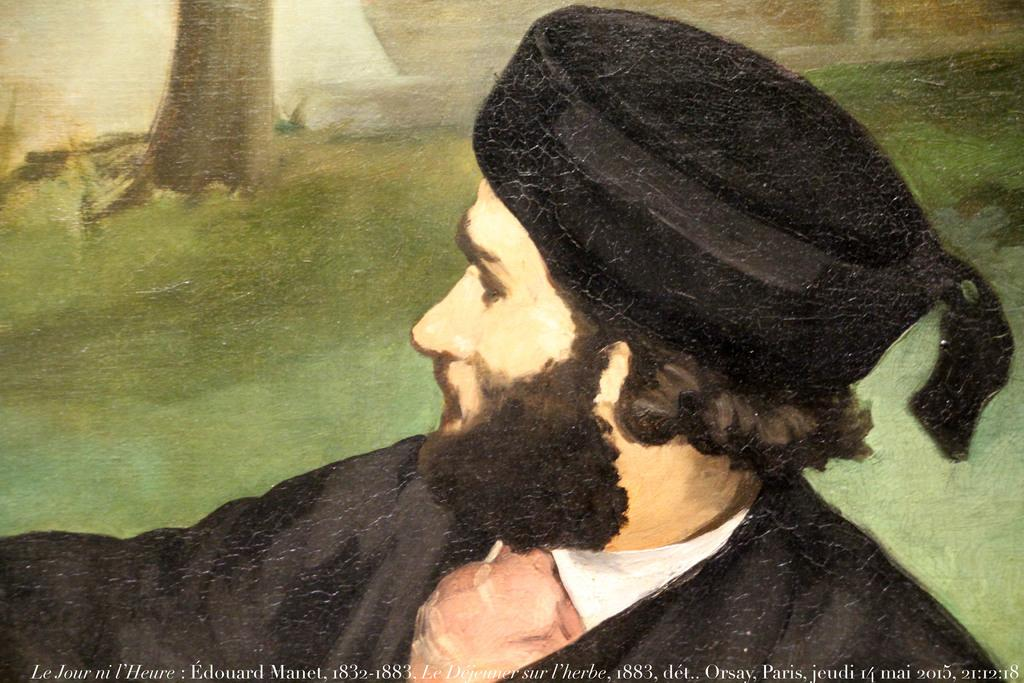What is the main subject of the painting? The painting depicts a person wearing a cap. Are there any natural elements in the painting? Yes, there is a truncated tree and grass present in the painting. What can be found at the bottom of the painting? There is text at the bottom of the painting. What type of animal can be seen walking in the direction of the person in the painting? There is no animal present in the painting, and therefore no such activity can be observed. 